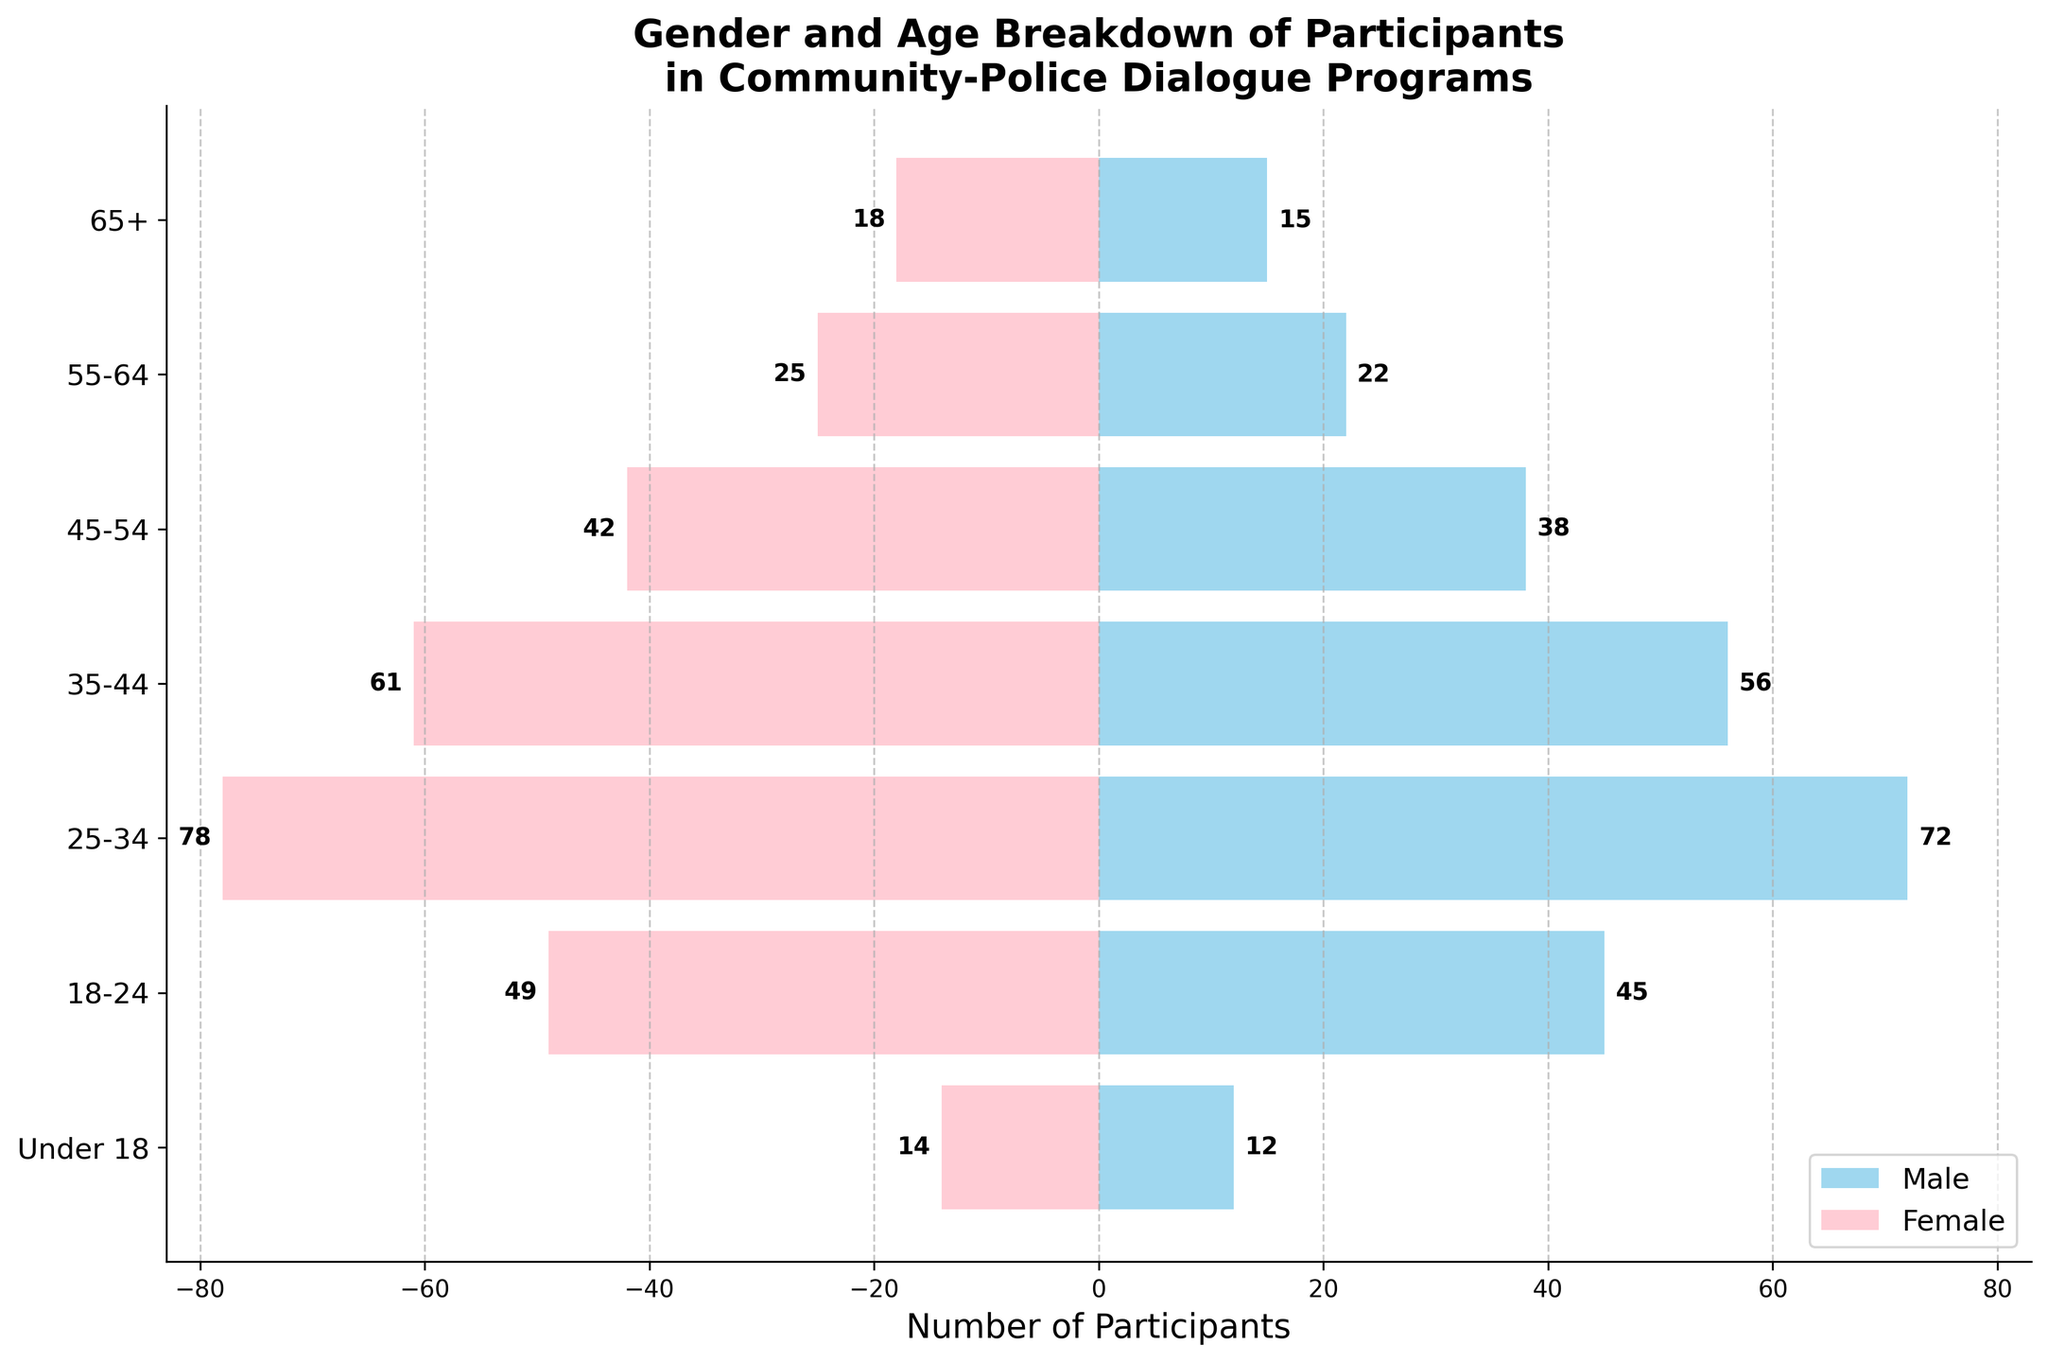Which age group has the highest number of female participants? Looking at the pink bars for the various age groups, the 25-34 age group has the longest bar for females.
Answer: 25-34 Which age group has the fewest male participants? By examining the length of the sky-blue bars, the Under 18 group has the shortest bar for males.
Answer: Under 18 What's the total number of participants in the 18-24 age group? Adding the male (45) and female (49) participants from the 18-24 age group, the total is 45 + 49.
Answer: 94 How many more participants are there in the 35-44 age group compared to the 45-54 age group? The 35-44 age group has 56 males and 61 females, summing up to 117. The 45-54 age group has 38 males and 42 females, totaling 80. The difference is 117 - 80.
Answer: 37 Which gender has more participants in the 55-64 age group? Comparing the lengths of the sky-blue and pink bars for the 55-64 group, the female bar is slightly longer.
Answer: Female What is the range of participants for males across all age groups? The male participants range from the 72 in 25-34 (maximum) to 12 in Under 18 (minimum). The range is 72 - 12.
Answer: 60 Are there more males or females in the age group '65+'? The number of males is 15 and the number of females is 18. Comparing these, there are more females.
Answer: Females What is the average number of female participants across all age groups? Summing the female participants (18+25+42+61+78+49+14) equals 287. Dividing by the 7 age groups gives 287 / 7.
Answer: 41 Which age group has the closest number of male and female participants? The 18-24 age group has 45 males and 49 females, with a difference of 4, which is smaller than any other age group's difference.
Answer: 18-24 